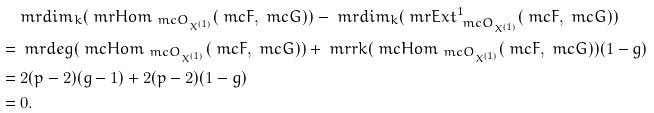Convert formula to latex. <formula><loc_0><loc_0><loc_500><loc_500>& \ m r { d i m } _ { k } ( \ m r { H o m } _ { \ m c O _ { X ^ { ( 1 ) } } } ( \ m c F , \ m c G ) ) - \ m r { d i m } _ { k } ( \ m r { E x t } _ { \ m c O _ { X ^ { ( 1 ) } } } ^ { 1 } ( \ m c F , \ m c G ) ) \\ = & \ \ m r { d e g } ( \ m c H o m _ { \ m c O _ { X ^ { ( 1 ) } } } ( \ m c F , \ m c G ) ) + \ m r { r k } ( \ m c H o m _ { \ m c O _ { X ^ { ( 1 ) } } } ( \ m c F , \ m c G ) ) ( 1 - g ) \\ = & \ 2 ( p - 2 ) ( g - 1 ) + 2 ( p - 2 ) ( 1 - g ) \\ = & \ 0 .</formula> 